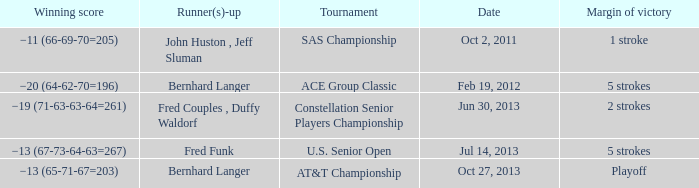Which Margin of victory has a Tournament of u.s. senior open? 5 strokes. 